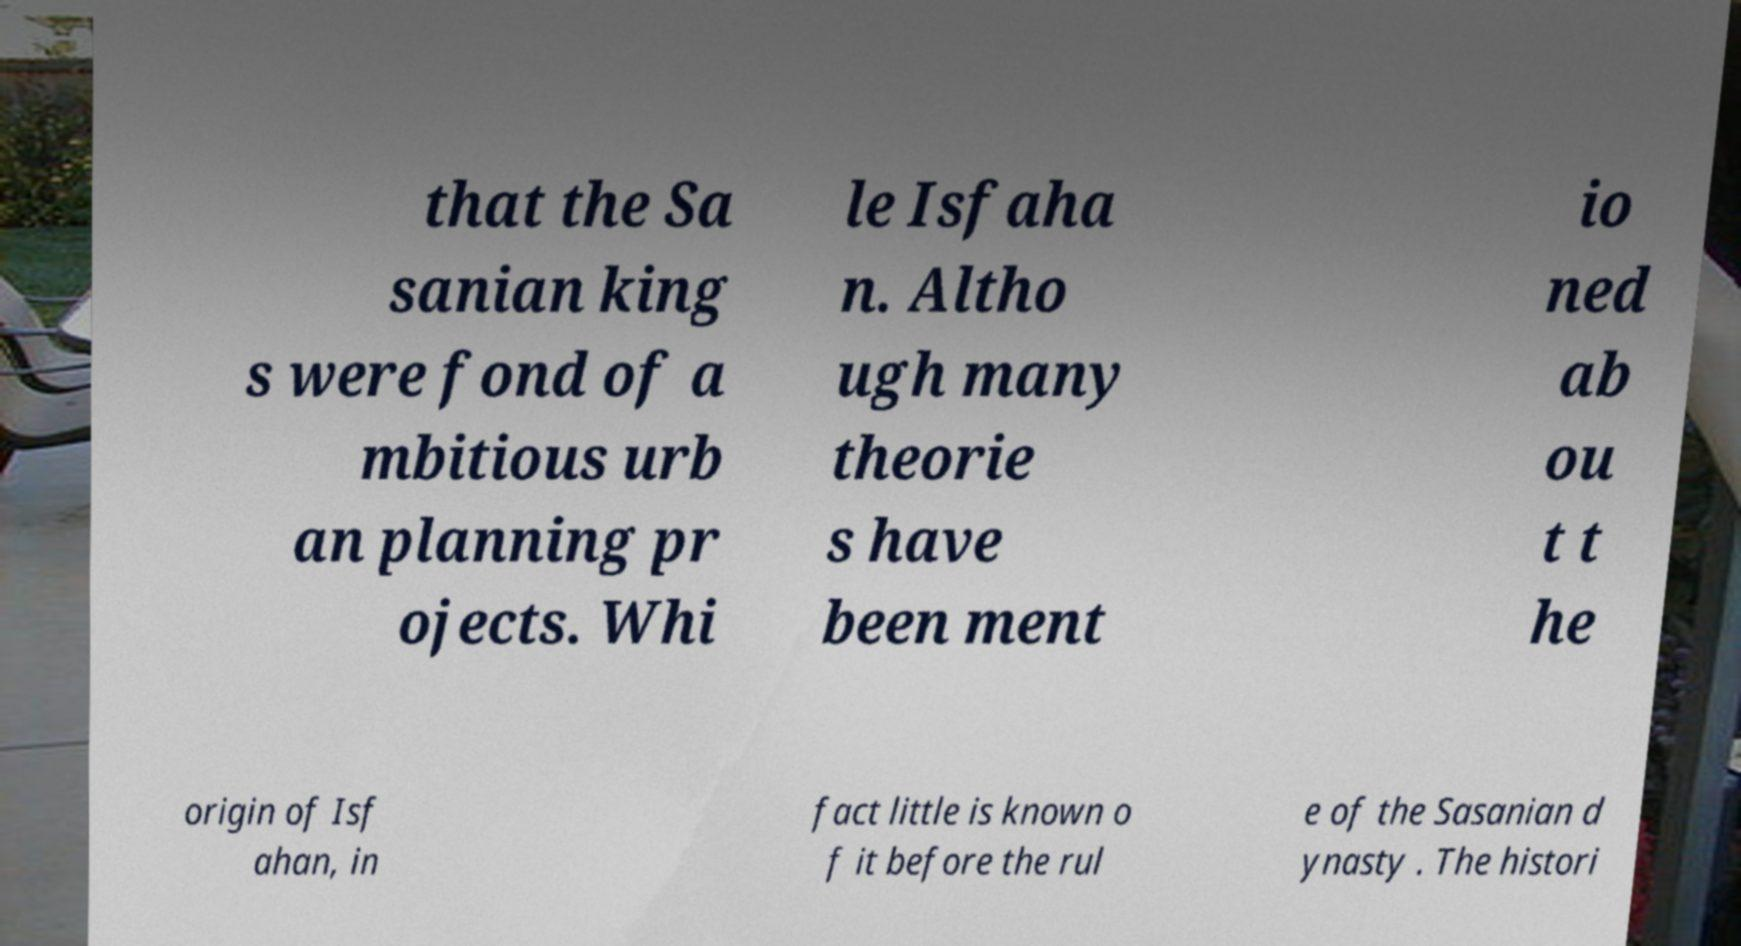I need the written content from this picture converted into text. Can you do that? that the Sa sanian king s were fond of a mbitious urb an planning pr ojects. Whi le Isfaha n. Altho ugh many theorie s have been ment io ned ab ou t t he origin of Isf ahan, in fact little is known o f it before the rul e of the Sasanian d ynasty . The histori 